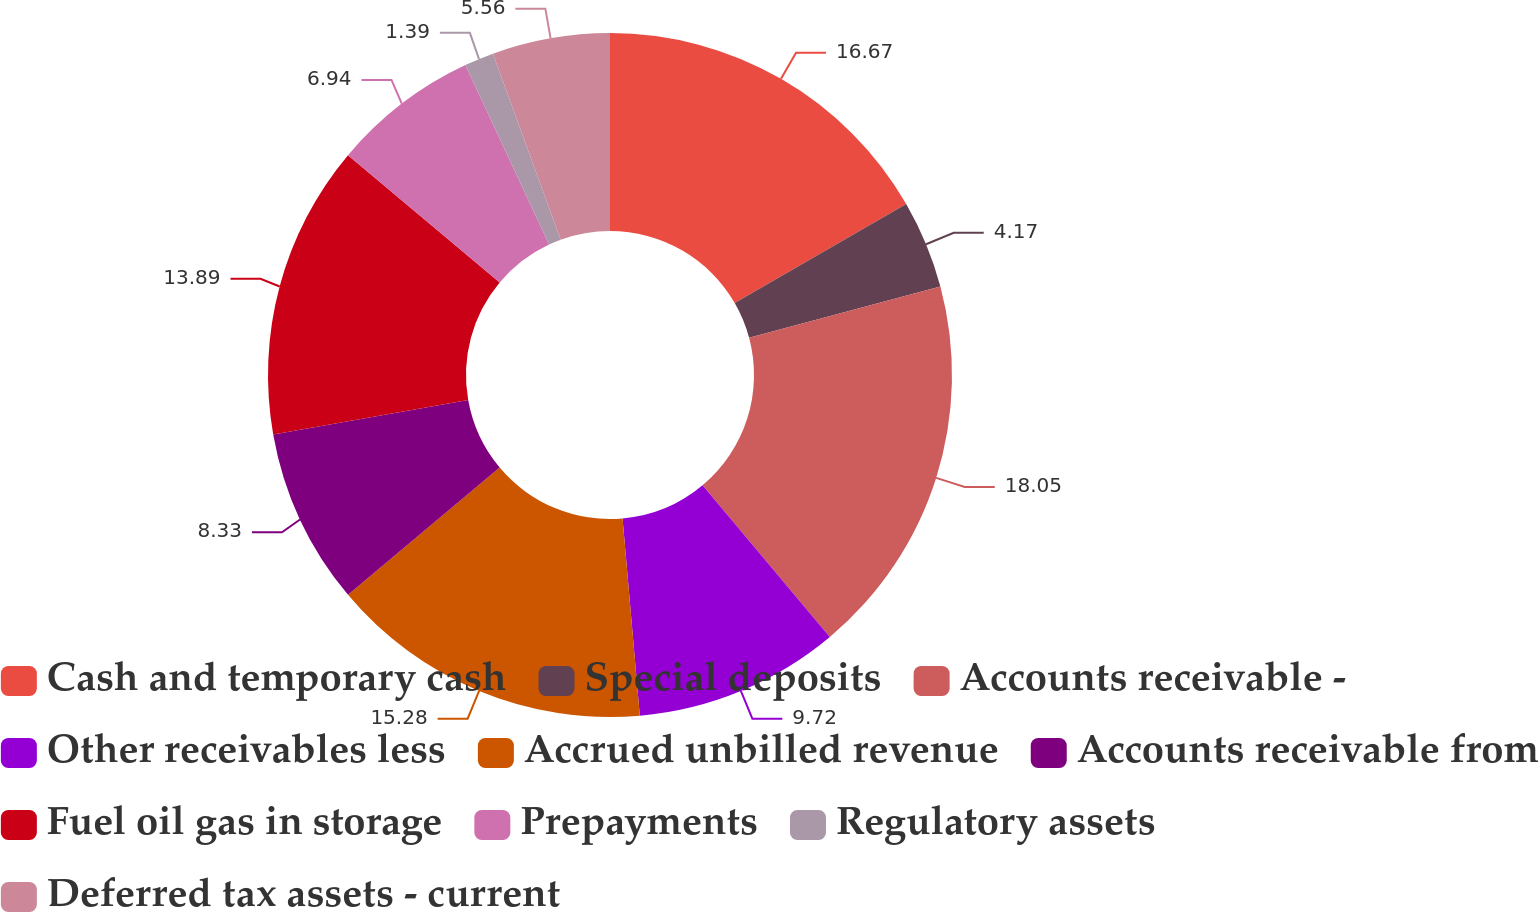<chart> <loc_0><loc_0><loc_500><loc_500><pie_chart><fcel>Cash and temporary cash<fcel>Special deposits<fcel>Accounts receivable -<fcel>Other receivables less<fcel>Accrued unbilled revenue<fcel>Accounts receivable from<fcel>Fuel oil gas in storage<fcel>Prepayments<fcel>Regulatory assets<fcel>Deferred tax assets - current<nl><fcel>16.67%<fcel>4.17%<fcel>18.05%<fcel>9.72%<fcel>15.28%<fcel>8.33%<fcel>13.89%<fcel>6.94%<fcel>1.39%<fcel>5.56%<nl></chart> 